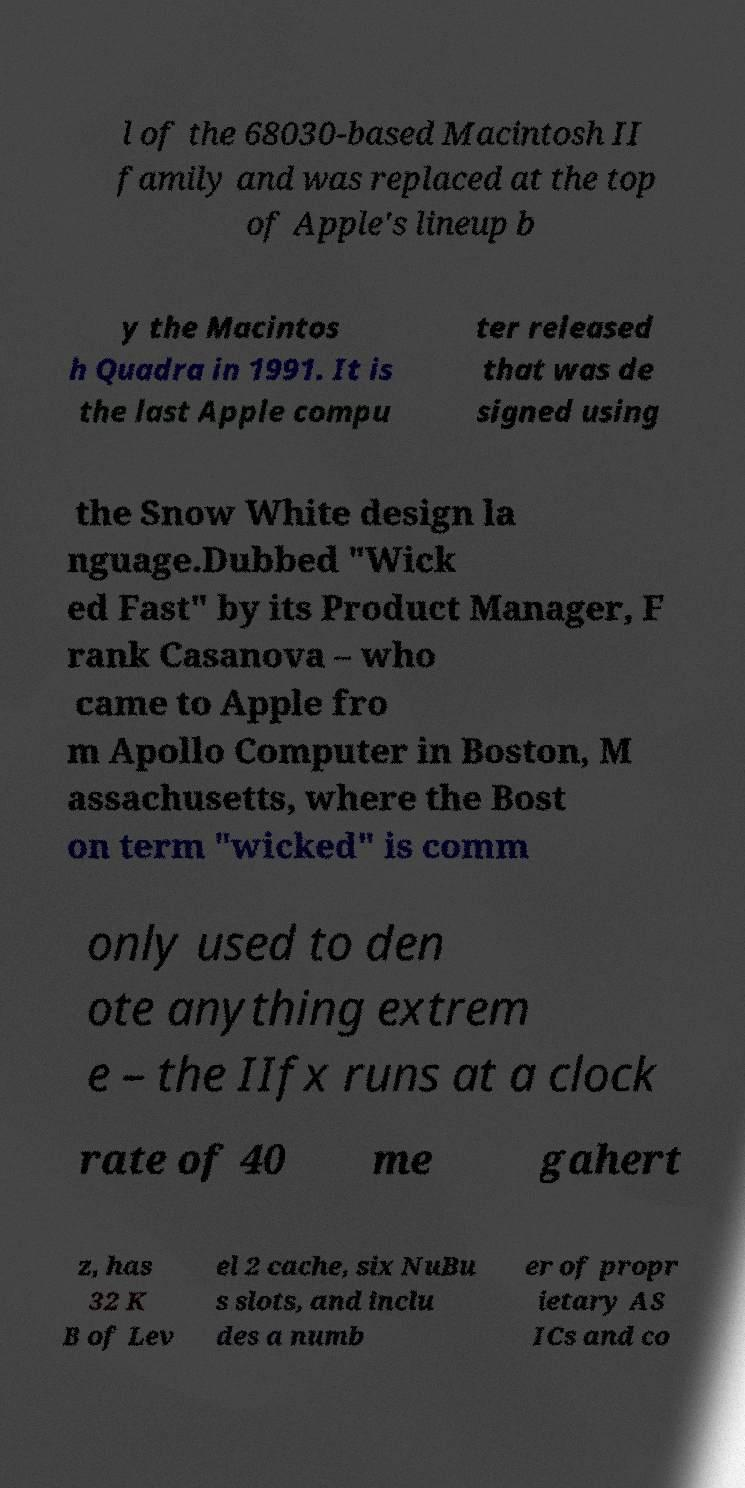Could you assist in decoding the text presented in this image and type it out clearly? l of the 68030-based Macintosh II family and was replaced at the top of Apple's lineup b y the Macintos h Quadra in 1991. It is the last Apple compu ter released that was de signed using the Snow White design la nguage.Dubbed "Wick ed Fast" by its Product Manager, F rank Casanova – who came to Apple fro m Apollo Computer in Boston, M assachusetts, where the Bost on term "wicked" is comm only used to den ote anything extrem e – the IIfx runs at a clock rate of 40 me gahert z, has 32 K B of Lev el 2 cache, six NuBu s slots, and inclu des a numb er of propr ietary AS ICs and co 